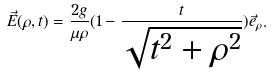Convert formula to latex. <formula><loc_0><loc_0><loc_500><loc_500>\vec { E } ( \rho , t ) = \frac { 2 g } { \mu \rho } ( 1 - \frac { t } { \sqrt { t ^ { 2 } + \rho ^ { 2 } } } ) \vec { e } _ { \rho } .</formula> 